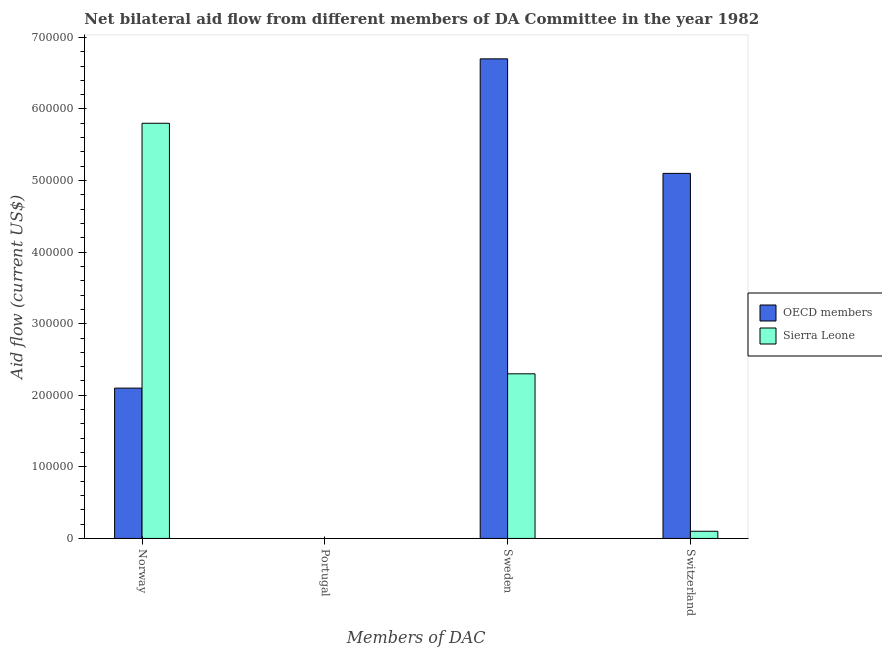Are the number of bars per tick equal to the number of legend labels?
Provide a short and direct response. No. How many bars are there on the 1st tick from the right?
Provide a short and direct response. 2. Across all countries, what is the maximum amount of aid given by sweden?
Your response must be concise. 6.70e+05. Across all countries, what is the minimum amount of aid given by portugal?
Offer a very short reply. 0. In which country was the amount of aid given by switzerland maximum?
Offer a terse response. OECD members. What is the total amount of aid given by sweden in the graph?
Keep it short and to the point. 9.00e+05. What is the difference between the amount of aid given by switzerland in OECD members and the amount of aid given by portugal in Sierra Leone?
Ensure brevity in your answer.  5.10e+05. What is the average amount of aid given by switzerland per country?
Your answer should be very brief. 2.60e+05. What is the difference between the amount of aid given by norway and amount of aid given by switzerland in Sierra Leone?
Offer a very short reply. 5.70e+05. In how many countries, is the amount of aid given by norway greater than 500000 US$?
Your response must be concise. 1. What is the ratio of the amount of aid given by sweden in Sierra Leone to that in OECD members?
Give a very brief answer. 0.34. Is the amount of aid given by switzerland in OECD members less than that in Sierra Leone?
Ensure brevity in your answer.  No. What is the difference between the highest and the lowest amount of aid given by switzerland?
Make the answer very short. 5.00e+05. In how many countries, is the amount of aid given by sweden greater than the average amount of aid given by sweden taken over all countries?
Keep it short and to the point. 1. Is it the case that in every country, the sum of the amount of aid given by portugal and amount of aid given by sweden is greater than the sum of amount of aid given by norway and amount of aid given by switzerland?
Provide a short and direct response. No. Is it the case that in every country, the sum of the amount of aid given by norway and amount of aid given by portugal is greater than the amount of aid given by sweden?
Offer a terse response. No. How many bars are there?
Ensure brevity in your answer.  8. Are all the bars in the graph horizontal?
Give a very brief answer. No. Where does the legend appear in the graph?
Your answer should be very brief. Center right. How are the legend labels stacked?
Ensure brevity in your answer.  Vertical. What is the title of the graph?
Make the answer very short. Net bilateral aid flow from different members of DA Committee in the year 1982. Does "Madagascar" appear as one of the legend labels in the graph?
Give a very brief answer. No. What is the label or title of the X-axis?
Give a very brief answer. Members of DAC. What is the label or title of the Y-axis?
Ensure brevity in your answer.  Aid flow (current US$). What is the Aid flow (current US$) in OECD members in Norway?
Give a very brief answer. 2.10e+05. What is the Aid flow (current US$) in Sierra Leone in Norway?
Provide a succinct answer. 5.80e+05. What is the Aid flow (current US$) in OECD members in Portugal?
Provide a succinct answer. Nan. What is the Aid flow (current US$) of Sierra Leone in Portugal?
Ensure brevity in your answer.  Nan. What is the Aid flow (current US$) of OECD members in Sweden?
Offer a terse response. 6.70e+05. What is the Aid flow (current US$) of OECD members in Switzerland?
Provide a succinct answer. 5.10e+05. What is the Aid flow (current US$) in Sierra Leone in Switzerland?
Your answer should be compact. 10000. Across all Members of DAC, what is the maximum Aid flow (current US$) in OECD members?
Give a very brief answer. 6.70e+05. Across all Members of DAC, what is the maximum Aid flow (current US$) of Sierra Leone?
Offer a very short reply. 5.80e+05. What is the total Aid flow (current US$) in OECD members in the graph?
Your response must be concise. 1.39e+06. What is the total Aid flow (current US$) in Sierra Leone in the graph?
Provide a short and direct response. 8.20e+05. What is the difference between the Aid flow (current US$) in OECD members in Norway and that in Portugal?
Ensure brevity in your answer.  Nan. What is the difference between the Aid flow (current US$) of Sierra Leone in Norway and that in Portugal?
Ensure brevity in your answer.  Nan. What is the difference between the Aid flow (current US$) of OECD members in Norway and that in Sweden?
Give a very brief answer. -4.60e+05. What is the difference between the Aid flow (current US$) of OECD members in Norway and that in Switzerland?
Keep it short and to the point. -3.00e+05. What is the difference between the Aid flow (current US$) in Sierra Leone in Norway and that in Switzerland?
Provide a short and direct response. 5.70e+05. What is the difference between the Aid flow (current US$) of OECD members in Portugal and that in Sweden?
Make the answer very short. Nan. What is the difference between the Aid flow (current US$) in Sierra Leone in Portugal and that in Sweden?
Offer a very short reply. Nan. What is the difference between the Aid flow (current US$) of OECD members in Portugal and that in Switzerland?
Your response must be concise. Nan. What is the difference between the Aid flow (current US$) in Sierra Leone in Portugal and that in Switzerland?
Your answer should be compact. Nan. What is the difference between the Aid flow (current US$) of OECD members in Sweden and that in Switzerland?
Provide a succinct answer. 1.60e+05. What is the difference between the Aid flow (current US$) of Sierra Leone in Sweden and that in Switzerland?
Provide a short and direct response. 2.20e+05. What is the difference between the Aid flow (current US$) of OECD members in Norway and the Aid flow (current US$) of Sierra Leone in Portugal?
Give a very brief answer. Nan. What is the difference between the Aid flow (current US$) of OECD members in Portugal and the Aid flow (current US$) of Sierra Leone in Sweden?
Your response must be concise. Nan. What is the difference between the Aid flow (current US$) of OECD members in Portugal and the Aid flow (current US$) of Sierra Leone in Switzerland?
Make the answer very short. Nan. What is the difference between the Aid flow (current US$) in OECD members in Sweden and the Aid flow (current US$) in Sierra Leone in Switzerland?
Offer a terse response. 6.60e+05. What is the average Aid flow (current US$) in OECD members per Members of DAC?
Give a very brief answer. 3.48e+05. What is the average Aid flow (current US$) in Sierra Leone per Members of DAC?
Your response must be concise. 2.05e+05. What is the difference between the Aid flow (current US$) in OECD members and Aid flow (current US$) in Sierra Leone in Norway?
Give a very brief answer. -3.70e+05. What is the difference between the Aid flow (current US$) of OECD members and Aid flow (current US$) of Sierra Leone in Portugal?
Keep it short and to the point. Nan. What is the difference between the Aid flow (current US$) in OECD members and Aid flow (current US$) in Sierra Leone in Switzerland?
Your response must be concise. 5.00e+05. What is the ratio of the Aid flow (current US$) in OECD members in Norway to that in Portugal?
Offer a terse response. Nan. What is the ratio of the Aid flow (current US$) in Sierra Leone in Norway to that in Portugal?
Offer a terse response. Nan. What is the ratio of the Aid flow (current US$) in OECD members in Norway to that in Sweden?
Offer a terse response. 0.31. What is the ratio of the Aid flow (current US$) in Sierra Leone in Norway to that in Sweden?
Ensure brevity in your answer.  2.52. What is the ratio of the Aid flow (current US$) of OECD members in Norway to that in Switzerland?
Your answer should be compact. 0.41. What is the ratio of the Aid flow (current US$) of Sierra Leone in Norway to that in Switzerland?
Your answer should be compact. 58. What is the ratio of the Aid flow (current US$) in OECD members in Portugal to that in Sweden?
Offer a very short reply. Nan. What is the ratio of the Aid flow (current US$) of Sierra Leone in Portugal to that in Sweden?
Make the answer very short. Nan. What is the ratio of the Aid flow (current US$) of OECD members in Portugal to that in Switzerland?
Offer a terse response. Nan. What is the ratio of the Aid flow (current US$) of Sierra Leone in Portugal to that in Switzerland?
Your answer should be very brief. Nan. What is the ratio of the Aid flow (current US$) in OECD members in Sweden to that in Switzerland?
Keep it short and to the point. 1.31. What is the ratio of the Aid flow (current US$) in Sierra Leone in Sweden to that in Switzerland?
Give a very brief answer. 23. What is the difference between the highest and the second highest Aid flow (current US$) of Sierra Leone?
Provide a succinct answer. 3.50e+05. What is the difference between the highest and the lowest Aid flow (current US$) in Sierra Leone?
Your answer should be very brief. 5.70e+05. 